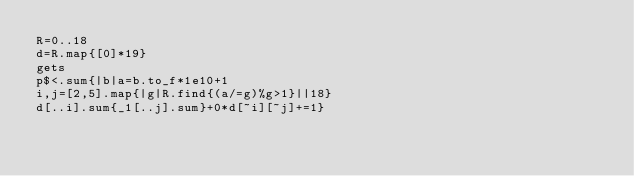<code> <loc_0><loc_0><loc_500><loc_500><_Ruby_>R=0..18
d=R.map{[0]*19}
gets
p$<.sum{|b|a=b.to_f*1e10+1
i,j=[2,5].map{|g|R.find{(a/=g)%g>1}||18}
d[..i].sum{_1[..j].sum}+0*d[~i][~j]+=1}</code> 